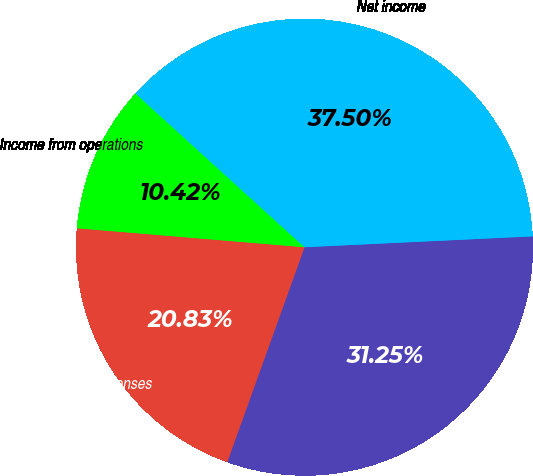<chart> <loc_0><loc_0><loc_500><loc_500><pie_chart><fcel>Gross profit<fcel>Operating expenses<fcel>Income from operations<fcel>Net income<nl><fcel>31.25%<fcel>20.83%<fcel>10.42%<fcel>37.5%<nl></chart> 